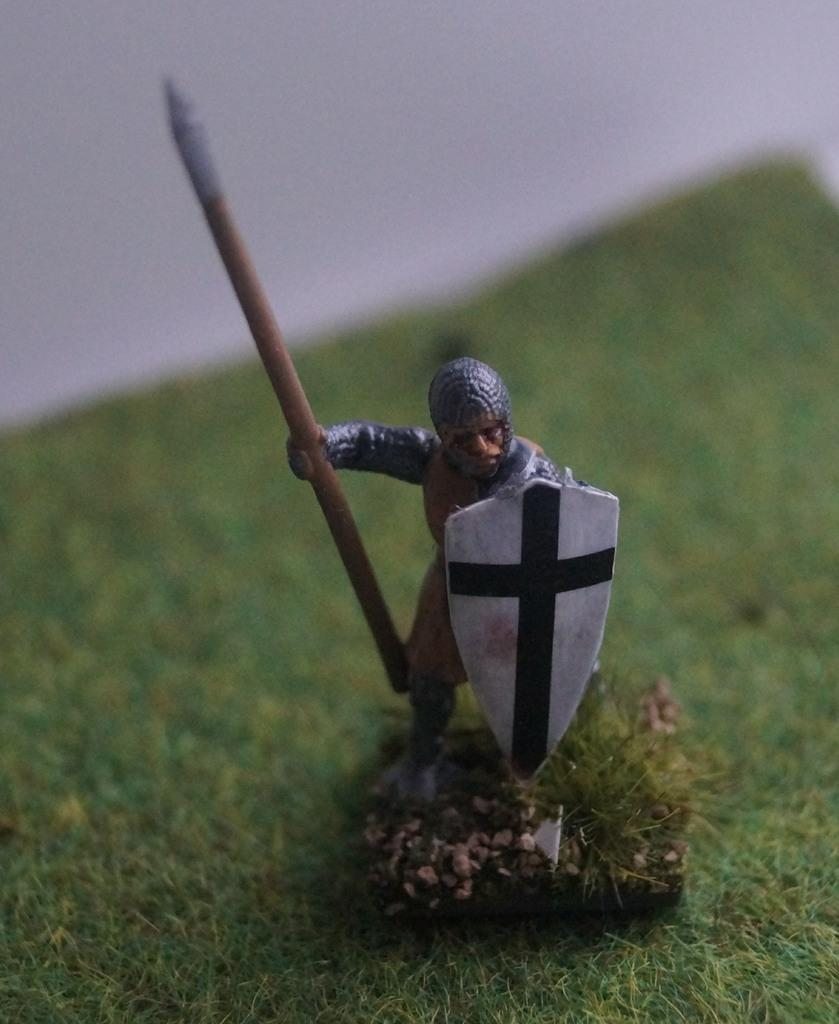What type of object is in the image that resembles a person? There is a toy of a person in the image. What is the toy person holding in their hand? The toy person is holding a wooden stick. What else is the toy person holding? The toy person is also holding a shield. What can be seen in the background of the image? There is grass visible in the background of the image. How would you describe the appearance of the background? The background of the image is blurred. How does the toy person plan to join the mark in the image? There is no mark present in the image, and the toy person is not shown attempting to join anything. 